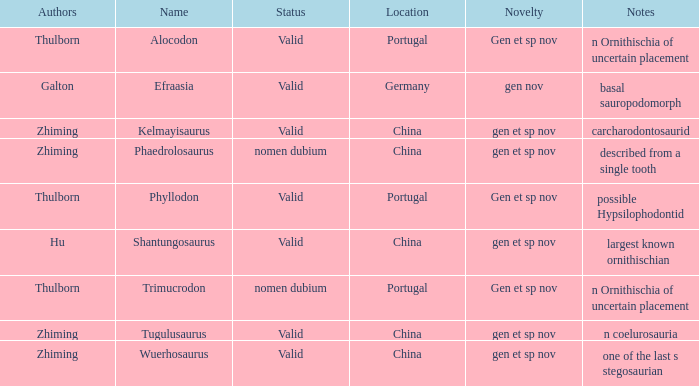What are the Notes of the dinosaur, whose Status is nomen dubium, and whose Location is China? Described from a single tooth. 